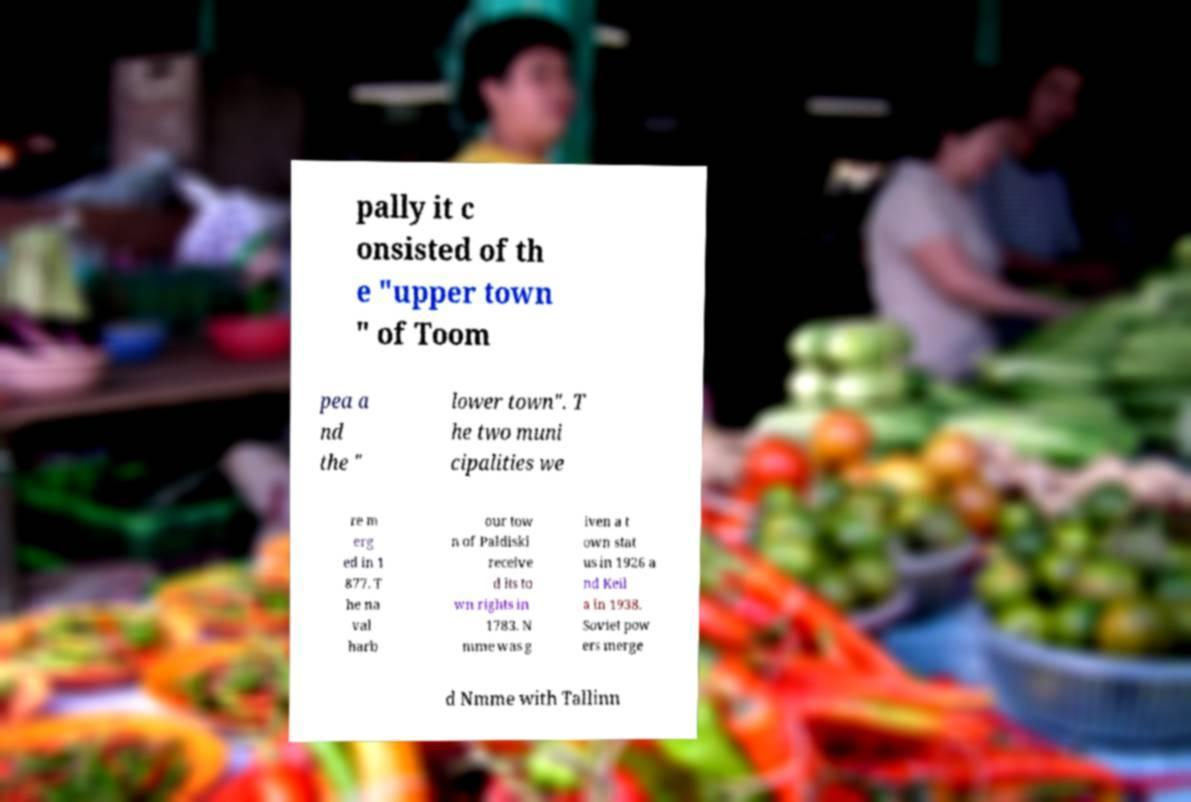Can you read and provide the text displayed in the image?This photo seems to have some interesting text. Can you extract and type it out for me? pally it c onsisted of th e "upper town " of Toom pea a nd the " lower town". T he two muni cipalities we re m erg ed in 1 877. T he na val harb our tow n of Paldiski receive d its to wn rights in 1783. N mme was g iven a t own stat us in 1926 a nd Keil a in 1938. Soviet pow ers merge d Nmme with Tallinn 